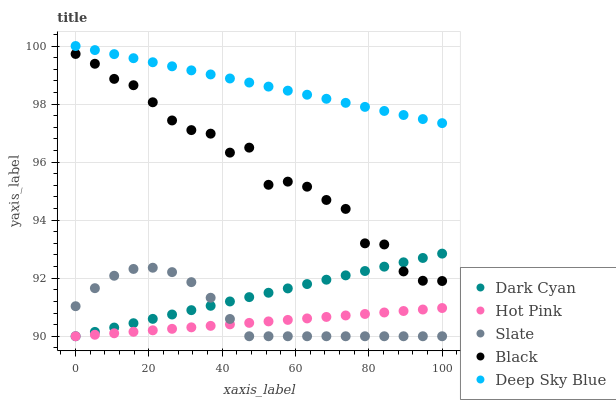Does Hot Pink have the minimum area under the curve?
Answer yes or no. Yes. Does Deep Sky Blue have the maximum area under the curve?
Answer yes or no. Yes. Does Slate have the minimum area under the curve?
Answer yes or no. No. Does Slate have the maximum area under the curve?
Answer yes or no. No. Is Deep Sky Blue the smoothest?
Answer yes or no. Yes. Is Black the roughest?
Answer yes or no. Yes. Is Slate the smoothest?
Answer yes or no. No. Is Slate the roughest?
Answer yes or no. No. Does Dark Cyan have the lowest value?
Answer yes or no. Yes. Does Black have the lowest value?
Answer yes or no. No. Does Deep Sky Blue have the highest value?
Answer yes or no. Yes. Does Slate have the highest value?
Answer yes or no. No. Is Slate less than Black?
Answer yes or no. Yes. Is Deep Sky Blue greater than Hot Pink?
Answer yes or no. Yes. Does Slate intersect Hot Pink?
Answer yes or no. Yes. Is Slate less than Hot Pink?
Answer yes or no. No. Is Slate greater than Hot Pink?
Answer yes or no. No. Does Slate intersect Black?
Answer yes or no. No. 